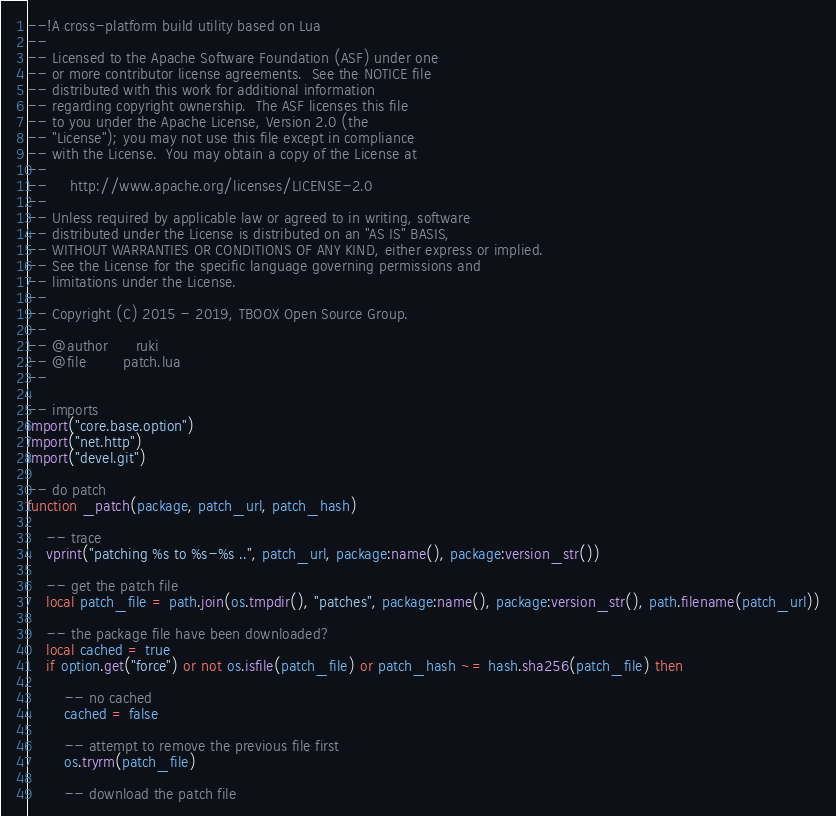<code> <loc_0><loc_0><loc_500><loc_500><_Lua_>--!A cross-platform build utility based on Lua
--
-- Licensed to the Apache Software Foundation (ASF) under one
-- or more contributor license agreements.  See the NOTICE file
-- distributed with this work for additional information
-- regarding copyright ownership.  The ASF licenses this file
-- to you under the Apache License, Version 2.0 (the
-- "License"); you may not use this file except in compliance
-- with the License.  You may obtain a copy of the License at
--
--     http://www.apache.org/licenses/LICENSE-2.0
--
-- Unless required by applicable law or agreed to in writing, software
-- distributed under the License is distributed on an "AS IS" BASIS,
-- WITHOUT WARRANTIES OR CONDITIONS OF ANY KIND, either express or implied.
-- See the License for the specific language governing permissions and
-- limitations under the License.
-- 
-- Copyright (C) 2015 - 2019, TBOOX Open Source Group.
--
-- @author      ruki
-- @file        patch.lua
--

-- imports
import("core.base.option")
import("net.http")
import("devel.git")

-- do patch
function _patch(package, patch_url, patch_hash)

    -- trace
    vprint("patching %s to %s-%s ..", patch_url, package:name(), package:version_str())
 
    -- get the patch file
    local patch_file = path.join(os.tmpdir(), "patches", package:name(), package:version_str(), path.filename(patch_url))

    -- the package file have been downloaded?
    local cached = true
    if option.get("force") or not os.isfile(patch_file) or patch_hash ~= hash.sha256(patch_file) then

        -- no cached
        cached = false

        -- attempt to remove the previous file first
        os.tryrm(patch_file)

        -- download the patch file</code> 